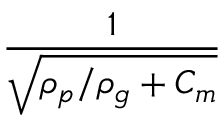<formula> <loc_0><loc_0><loc_500><loc_500>\frac { 1 } { \sqrt { \rho _ { p } / \rho _ { g } + C _ { m } } }</formula> 